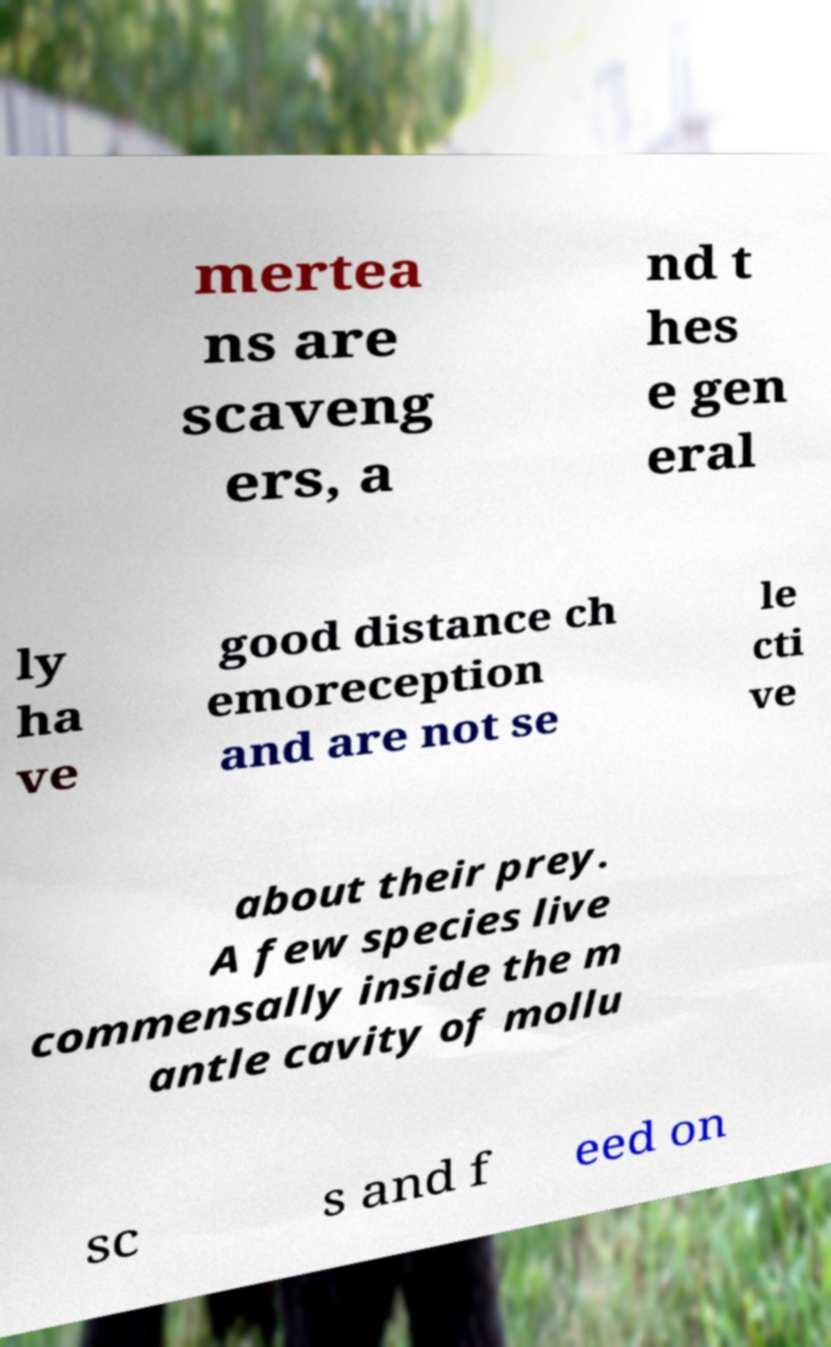Please identify and transcribe the text found in this image. mertea ns are scaveng ers, a nd t hes e gen eral ly ha ve good distance ch emoreception and are not se le cti ve about their prey. A few species live commensally inside the m antle cavity of mollu sc s and f eed on 